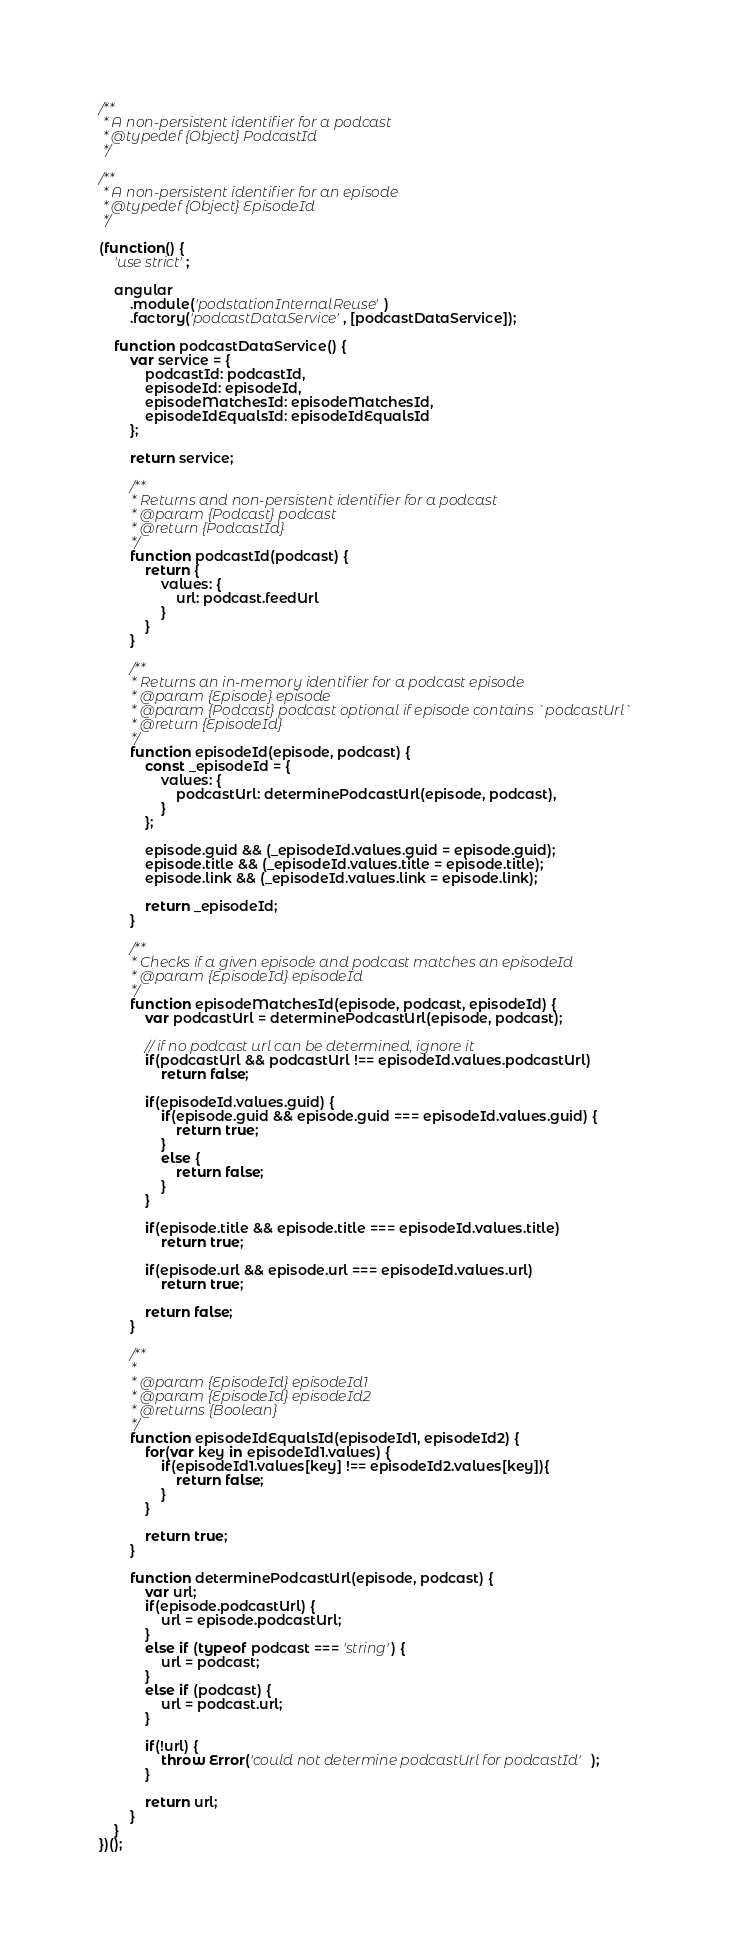Convert code to text. <code><loc_0><loc_0><loc_500><loc_500><_JavaScript_>/**
 * A non-persistent identifier for a podcast
 * @typedef {Object} PodcastId
 */

/**
 * A non-persistent identifier for an episode
 * @typedef {Object} EpisodeId
 */

(function() {
	'use strict';

	angular
		.module('podstationInternalReuse')
		.factory('podcastDataService', [podcastDataService]);

	function podcastDataService() {
		var service = {
			podcastId: podcastId,
			episodeId: episodeId,
			episodeMatchesId: episodeMatchesId,
			episodeIdEqualsId: episodeIdEqualsId
		};

		return service;

		/**
		 * Returns and non-persistent identifier for a podcast
		 * @param {Podcast} podcast 
		 * @return {PodcastId}
		 */
		function podcastId(podcast) {
			return {
				values: {
					url: podcast.feedUrl
				}
			}
		}

		/**
		 * Returns an in-memory identifier for a podcast episode
		 * @param {Episode} episode
		 * @param {Podcast} podcast optional if episode contains `podcastUrl`
		 * @return {EpisodeId}
		 */
		function episodeId(episode, podcast) {
			const _episodeId = {
				values: {
					podcastUrl: determinePodcastUrl(episode, podcast),
				}
			};

			episode.guid && (_episodeId.values.guid = episode.guid);
			episode.title && (_episodeId.values.title = episode.title);
			episode.link && (_episodeId.values.link = episode.link);

			return _episodeId;
		}

		/**
		 * Checks if a given episode and podcast matches an episodeId
		 * @param {EpisodeId} episodeId
		 */
		function episodeMatchesId(episode, podcast, episodeId) {
			var podcastUrl = determinePodcastUrl(episode, podcast);

			// if no podcast url can be determined, ignore it
			if(podcastUrl && podcastUrl !== episodeId.values.podcastUrl)
				return false;

			if(episodeId.values.guid) {
				if(episode.guid && episode.guid === episodeId.values.guid) {
					return true;
				}
				else {
					return false;
				}
			}

			if(episode.title && episode.title === episodeId.values.title)
				return true;

			if(episode.url && episode.url === episodeId.values.url)
				return true;

			return false;
		}

		/**
		 * 
		 * @param {EpisodeId} episodeId1 
		 * @param {EpisodeId} episodeId2 
		 * @returns {Boolean}
		 */
		function episodeIdEqualsId(episodeId1, episodeId2) {
			for(var key in episodeId1.values) {
				if(episodeId1.values[key] !== episodeId2.values[key]){
					return false;
				}
			}

			return true;
		}

		function determinePodcastUrl(episode, podcast) {
			var url;
			if(episode.podcastUrl) {
				url = episode.podcastUrl;
			}
			else if (typeof podcast === 'string') {
				url = podcast;
			}
			else if (podcast) {
				url = podcast.url;
			}

			if(!url) {
				throw Error('could not determine podcastUrl for podcastId');
			}

			return url;
		}
	}
})();</code> 